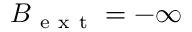<formula> <loc_0><loc_0><loc_500><loc_500>B _ { e x t } = - \infty</formula> 